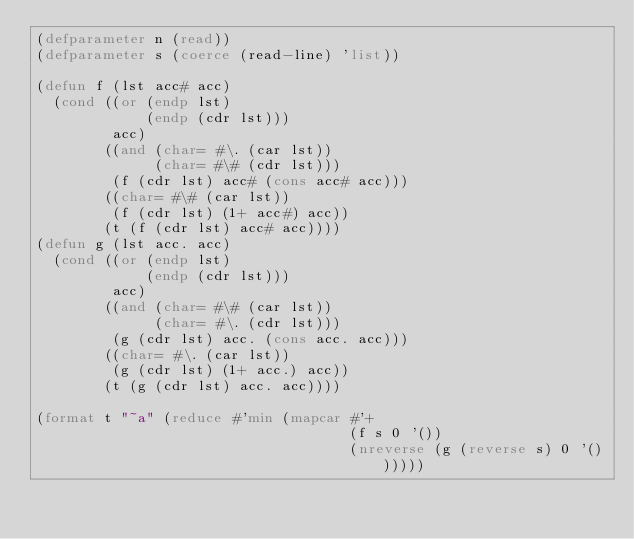Convert code to text. <code><loc_0><loc_0><loc_500><loc_500><_Lisp_>(defparameter n (read))
(defparameter s (coerce (read-line) 'list))

(defun f (lst acc# acc)
  (cond ((or (endp lst)
             (endp (cdr lst)))
         acc)
        ((and (char= #\. (car lst))
              (char= #\# (cdr lst)))
         (f (cdr lst) acc# (cons acc# acc)))
        ((char= #\# (car lst))
         (f (cdr lst) (1+ acc#) acc))
        (t (f (cdr lst) acc# acc))))
(defun g (lst acc. acc)
  (cond ((or (endp lst)
             (endp (cdr lst)))
         acc)
        ((and (char= #\# (car lst))
              (char= #\. (cdr lst)))
         (g (cdr lst) acc. (cons acc. acc)))
        ((char= #\. (car lst))
         (g (cdr lst) (1+ acc.) acc))
        (t (g (cdr lst) acc. acc))))

(format t "~a" (reduce #'min (mapcar #'+
                                     (f s 0 '())
                                     (nreverse (g (reverse s) 0 '())))))</code> 